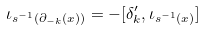Convert formula to latex. <formula><loc_0><loc_0><loc_500><loc_500>\iota _ { s ^ { - 1 } ( \partial _ { - k } ( x ) ) } = - [ \delta ^ { \prime } _ { k } , \iota _ { s ^ { - 1 } ( x ) } ]</formula> 